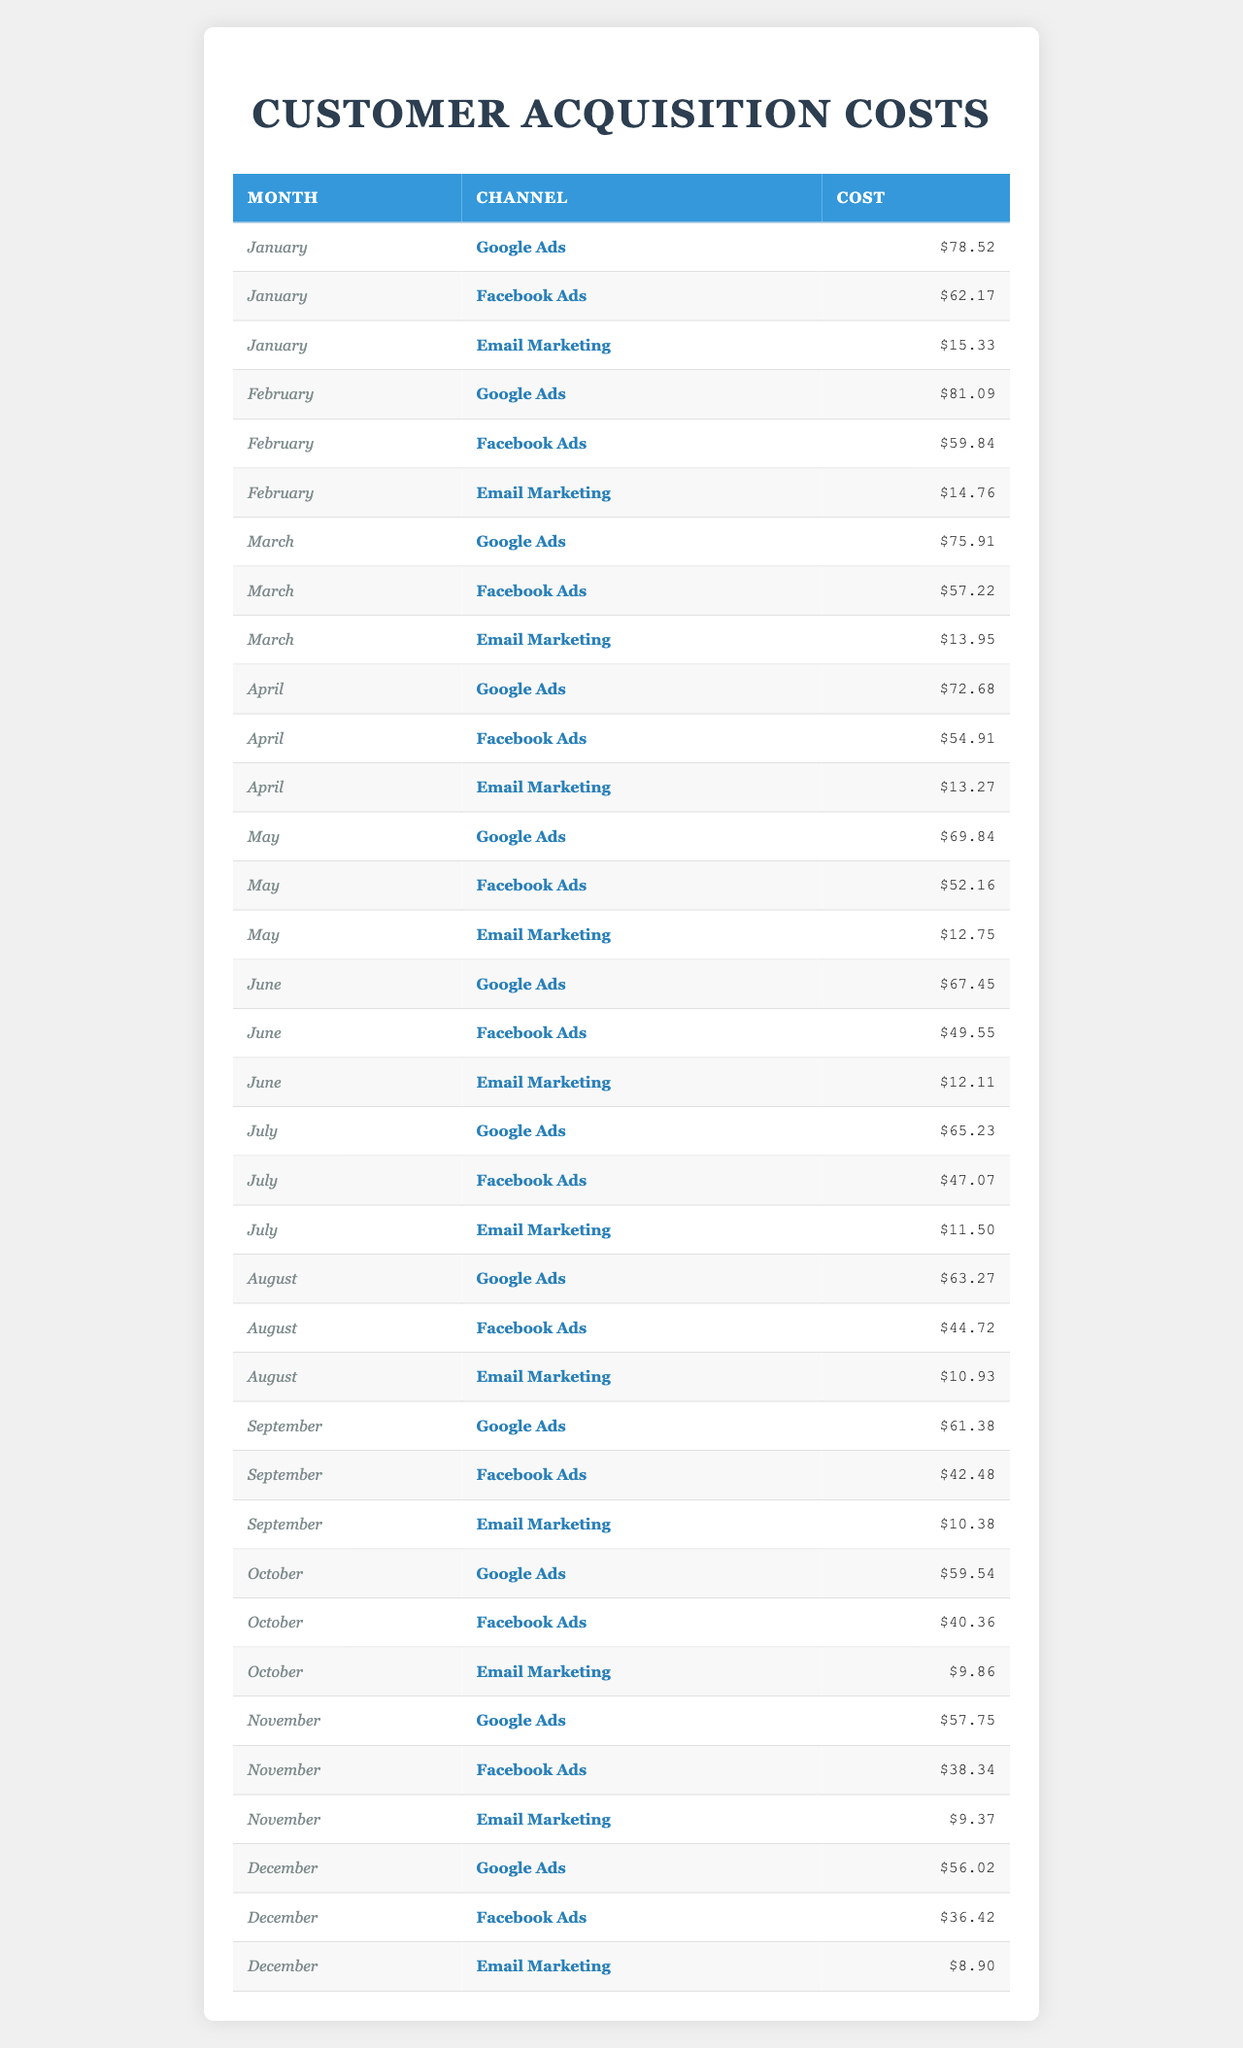What was the customer acquisition cost for Facebook Ads in December? In the table, for December under the Facebook Ads channel, the customer acquisition cost is listed as $36.42.
Answer: $36.42 Which marketing channel had the lowest customer acquisition cost in July? Looking at the July row, Email Marketing has the lowest customer acquisition cost of $11.50 compared to Google Ads and Facebook Ads.
Answer: Email Marketing What is the average customer acquisition cost for Email Marketing over the 12 months? The costs for Email Marketing are: 15.33, 14.76, 13.95, 13.27, 12.75, 12.11, 11.50, 10.93, 10.38, 9.86, 9.37, 8.90. Summing these values yields  150.01, which divided by 12 gives an average of 12.50.
Answer: $12.50 Did the customer acquisition cost for Google Ads decrease every month? We can examine the monthly values for Google Ads: 78.52, 81.09, 75.91, 72.68, 69.84, 67.45, 65.23, 63.27, 61.38, 59.54, 57.75, 56.02. Notably, the values did not decrease from January to February. Therefore, the statement is false.
Answer: No What is the total customer acquisition cost for Facebook Ads over all months? The monthly costs for Facebook Ads are: 62.17, 59.84, 57.22, 54.91, 52.16, 49.55, 47.07, 44.72, 42.48, 40.36, 38.34, 36.42. Summing these values results in $585.84.
Answer: $585.84 Which month had the highest customer acquisition cost for Google Ads? The table shows the monthly costs for Google Ads with the maximum value of $81.09 in February.
Answer: February What was the decline in customer acquisition cost for Email Marketing from January to December? The customer acquisition costs for Email Marketing are $15.33 in January and $8.90 in December. To find the decline, we subtract 8.90 from 15.33, resulting in a decline of $6.43.
Answer: $6.43 Was there more variation in the customer acquisition costs for any specific channel compared to others? By visually comparing the monthly costs for each channel, we can see that Google Ads shows less consistency compared to the stable trend seen in Email Marketing. However, to assert the variation mathematically, further calculations would be needed.
Answer: Yes, Google Ads shows more variation Which marketing channel consistently had the lowest customer acquisition cost throughout the year? By inspecting the monthly costs, Email Marketing is below both Google Ads and Facebook Ads for all months, indicating it has the lowest acquisition cost consistently.
Answer: Email Marketing What is the difference in customer acquisition cost between the highest month for Facebook Ads and the lowest month? The highest cost for Facebook Ads was $62.17 in January, and the lowest was $36.42 in December. The difference is found by subtracting the lower from the higher: 62.17 - 36.42 = 25.75.
Answer: $25.75 